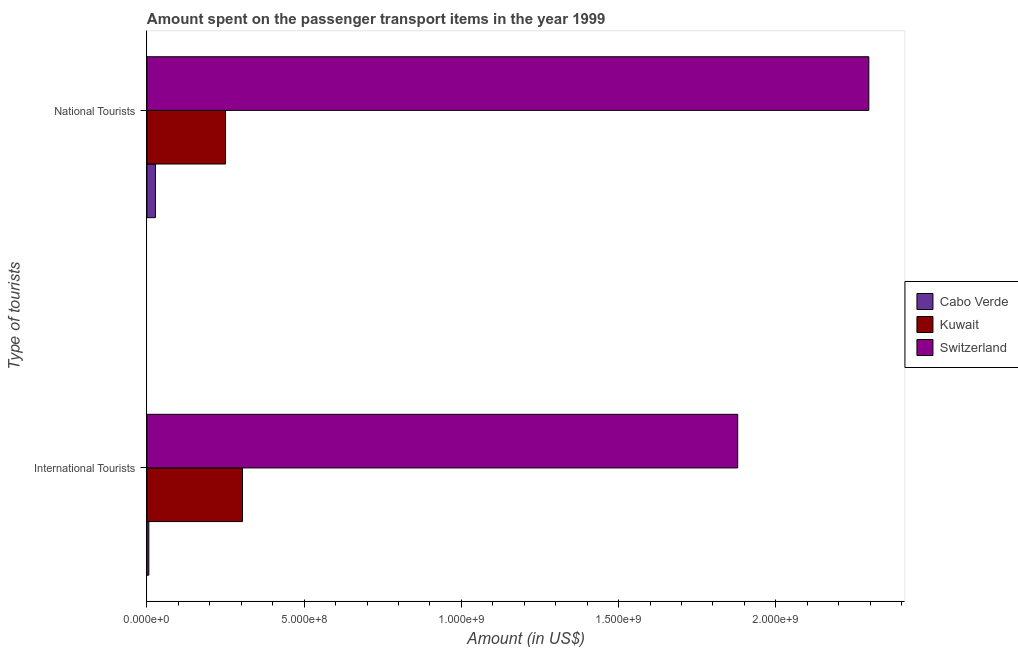How many groups of bars are there?
Offer a very short reply. 2. Are the number of bars on each tick of the Y-axis equal?
Your answer should be compact. Yes. How many bars are there on the 1st tick from the top?
Ensure brevity in your answer.  3. How many bars are there on the 1st tick from the bottom?
Make the answer very short. 3. What is the label of the 1st group of bars from the top?
Your response must be concise. National Tourists. What is the amount spent on transport items of national tourists in Cabo Verde?
Your response must be concise. 2.70e+07. Across all countries, what is the maximum amount spent on transport items of international tourists?
Your answer should be very brief. 1.88e+09. Across all countries, what is the minimum amount spent on transport items of international tourists?
Provide a succinct answer. 6.00e+06. In which country was the amount spent on transport items of national tourists maximum?
Offer a very short reply. Switzerland. In which country was the amount spent on transport items of national tourists minimum?
Ensure brevity in your answer.  Cabo Verde. What is the total amount spent on transport items of national tourists in the graph?
Your answer should be compact. 2.57e+09. What is the difference between the amount spent on transport items of national tourists in Kuwait and that in Cabo Verde?
Make the answer very short. 2.23e+08. What is the difference between the amount spent on transport items of international tourists in Cabo Verde and the amount spent on transport items of national tourists in Kuwait?
Offer a very short reply. -2.44e+08. What is the average amount spent on transport items of international tourists per country?
Keep it short and to the point. 7.30e+08. What is the difference between the amount spent on transport items of national tourists and amount spent on transport items of international tourists in Cabo Verde?
Offer a terse response. 2.10e+07. In how many countries, is the amount spent on transport items of international tourists greater than 1200000000 US$?
Your answer should be compact. 1. What is the ratio of the amount spent on transport items of national tourists in Cabo Verde to that in Kuwait?
Offer a terse response. 0.11. Is the amount spent on transport items of national tourists in Switzerland less than that in Cabo Verde?
Offer a terse response. No. What does the 2nd bar from the top in National Tourists represents?
Your answer should be compact. Kuwait. What does the 2nd bar from the bottom in National Tourists represents?
Give a very brief answer. Kuwait. How many bars are there?
Offer a terse response. 6. Are all the bars in the graph horizontal?
Your response must be concise. Yes. How many countries are there in the graph?
Give a very brief answer. 3. Are the values on the major ticks of X-axis written in scientific E-notation?
Your answer should be compact. Yes. Does the graph contain any zero values?
Your answer should be compact. No. Does the graph contain grids?
Keep it short and to the point. No. Where does the legend appear in the graph?
Your answer should be compact. Center right. How many legend labels are there?
Your answer should be compact. 3. What is the title of the graph?
Offer a very short reply. Amount spent on the passenger transport items in the year 1999. Does "United Arab Emirates" appear as one of the legend labels in the graph?
Make the answer very short. No. What is the label or title of the X-axis?
Offer a terse response. Amount (in US$). What is the label or title of the Y-axis?
Make the answer very short. Type of tourists. What is the Amount (in US$) of Cabo Verde in International Tourists?
Offer a terse response. 6.00e+06. What is the Amount (in US$) of Kuwait in International Tourists?
Keep it short and to the point. 3.04e+08. What is the Amount (in US$) in Switzerland in International Tourists?
Offer a very short reply. 1.88e+09. What is the Amount (in US$) of Cabo Verde in National Tourists?
Make the answer very short. 2.70e+07. What is the Amount (in US$) in Kuwait in National Tourists?
Your response must be concise. 2.50e+08. What is the Amount (in US$) in Switzerland in National Tourists?
Offer a terse response. 2.30e+09. Across all Type of tourists, what is the maximum Amount (in US$) in Cabo Verde?
Give a very brief answer. 2.70e+07. Across all Type of tourists, what is the maximum Amount (in US$) of Kuwait?
Make the answer very short. 3.04e+08. Across all Type of tourists, what is the maximum Amount (in US$) in Switzerland?
Your response must be concise. 2.30e+09. Across all Type of tourists, what is the minimum Amount (in US$) of Cabo Verde?
Your answer should be compact. 6.00e+06. Across all Type of tourists, what is the minimum Amount (in US$) in Kuwait?
Provide a succinct answer. 2.50e+08. Across all Type of tourists, what is the minimum Amount (in US$) of Switzerland?
Keep it short and to the point. 1.88e+09. What is the total Amount (in US$) of Cabo Verde in the graph?
Make the answer very short. 3.30e+07. What is the total Amount (in US$) of Kuwait in the graph?
Give a very brief answer. 5.54e+08. What is the total Amount (in US$) in Switzerland in the graph?
Provide a succinct answer. 4.18e+09. What is the difference between the Amount (in US$) in Cabo Verde in International Tourists and that in National Tourists?
Make the answer very short. -2.10e+07. What is the difference between the Amount (in US$) in Kuwait in International Tourists and that in National Tourists?
Offer a very short reply. 5.40e+07. What is the difference between the Amount (in US$) in Switzerland in International Tourists and that in National Tourists?
Give a very brief answer. -4.17e+08. What is the difference between the Amount (in US$) of Cabo Verde in International Tourists and the Amount (in US$) of Kuwait in National Tourists?
Your answer should be compact. -2.44e+08. What is the difference between the Amount (in US$) in Cabo Verde in International Tourists and the Amount (in US$) in Switzerland in National Tourists?
Offer a very short reply. -2.29e+09. What is the difference between the Amount (in US$) of Kuwait in International Tourists and the Amount (in US$) of Switzerland in National Tourists?
Provide a succinct answer. -1.99e+09. What is the average Amount (in US$) of Cabo Verde per Type of tourists?
Provide a succinct answer. 1.65e+07. What is the average Amount (in US$) of Kuwait per Type of tourists?
Provide a short and direct response. 2.77e+08. What is the average Amount (in US$) in Switzerland per Type of tourists?
Provide a succinct answer. 2.09e+09. What is the difference between the Amount (in US$) of Cabo Verde and Amount (in US$) of Kuwait in International Tourists?
Make the answer very short. -2.98e+08. What is the difference between the Amount (in US$) of Cabo Verde and Amount (in US$) of Switzerland in International Tourists?
Your response must be concise. -1.87e+09. What is the difference between the Amount (in US$) in Kuwait and Amount (in US$) in Switzerland in International Tourists?
Provide a succinct answer. -1.58e+09. What is the difference between the Amount (in US$) of Cabo Verde and Amount (in US$) of Kuwait in National Tourists?
Your response must be concise. -2.23e+08. What is the difference between the Amount (in US$) of Cabo Verde and Amount (in US$) of Switzerland in National Tourists?
Offer a very short reply. -2.27e+09. What is the difference between the Amount (in US$) in Kuwait and Amount (in US$) in Switzerland in National Tourists?
Make the answer very short. -2.05e+09. What is the ratio of the Amount (in US$) of Cabo Verde in International Tourists to that in National Tourists?
Give a very brief answer. 0.22. What is the ratio of the Amount (in US$) of Kuwait in International Tourists to that in National Tourists?
Keep it short and to the point. 1.22. What is the ratio of the Amount (in US$) in Switzerland in International Tourists to that in National Tourists?
Your response must be concise. 0.82. What is the difference between the highest and the second highest Amount (in US$) in Cabo Verde?
Provide a short and direct response. 2.10e+07. What is the difference between the highest and the second highest Amount (in US$) of Kuwait?
Your answer should be very brief. 5.40e+07. What is the difference between the highest and the second highest Amount (in US$) in Switzerland?
Your answer should be very brief. 4.17e+08. What is the difference between the highest and the lowest Amount (in US$) of Cabo Verde?
Ensure brevity in your answer.  2.10e+07. What is the difference between the highest and the lowest Amount (in US$) of Kuwait?
Ensure brevity in your answer.  5.40e+07. What is the difference between the highest and the lowest Amount (in US$) of Switzerland?
Your response must be concise. 4.17e+08. 